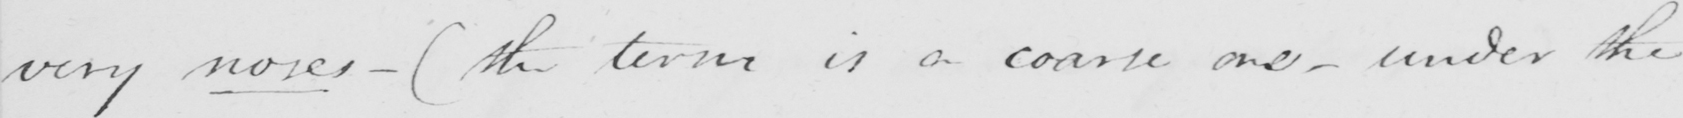Please transcribe the handwritten text in this image. very noses  _   ( the term is a coarse one  _  under the 